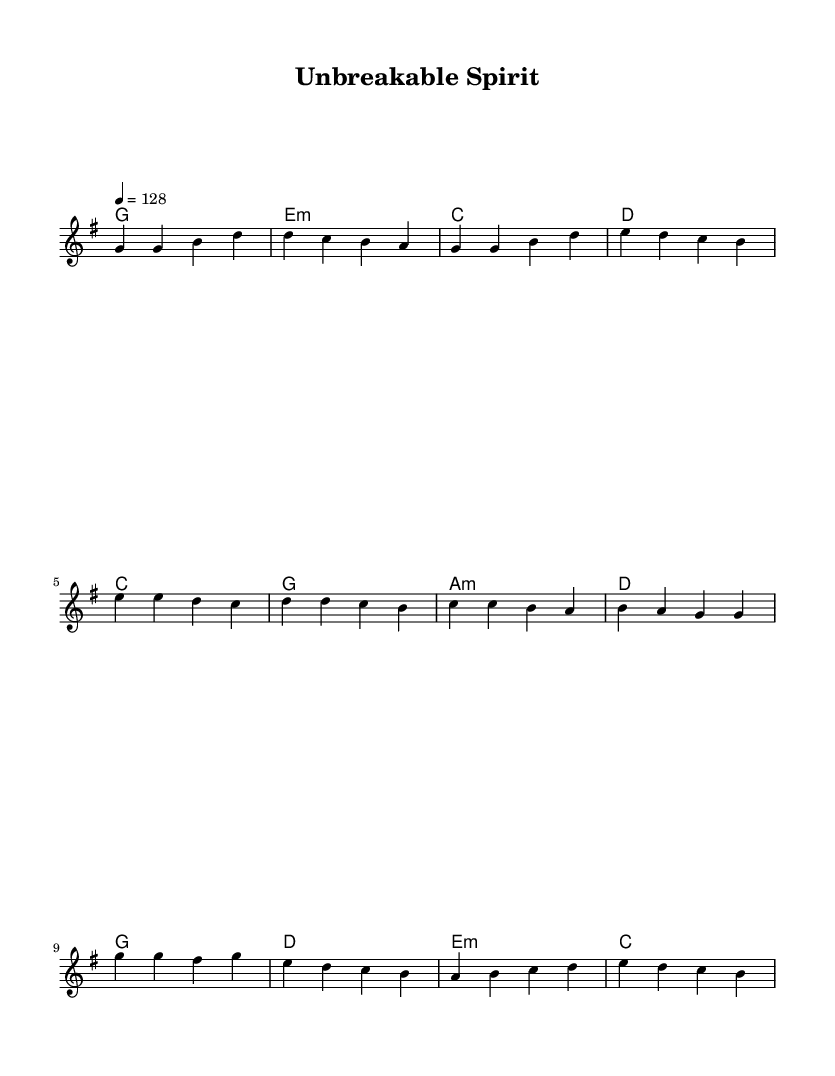What is the key signature of this music? The key signature is G major, which has one sharp (F#). This can be identified by looking at the key signature at the beginning of the score where one sharp is indicated.
Answer: G major What is the time signature of this music? The time signature is 4/4, which is displayed at the beginning of the score. In this case, it shows that there are four beats in each measure, making it a common signature for pop music.
Answer: 4/4 What is the tempo marking of this music? The tempo marking is 4 = 128. This indicates that there are 128 beats per minute, which establishes the pace of the song. It's indicated at the beginning of the score, near the time signature.
Answer: 128 How many measures are in the verse section? The verse section consists of 4 measures. This can be counted by looking at the melody and harmonies written out, identifying the bars separated by vertical lines.
Answer: 4 What is the main theme of the chorus lyrics? The main theme of the chorus lyrics revolves around perseverance and fighting through challenges. Analyzing the chorus words reveals a strong message about an unbreakable spirit, rising above adversity with hope and love.
Answer: Perseverance How many unique chords are used in the verse section? There are three unique chords used in the verse section: G, E minor, and D. This is determined by examining the chord symbols listed underneath the melody for the verse and noting each distinct chord.
Answer: 3 